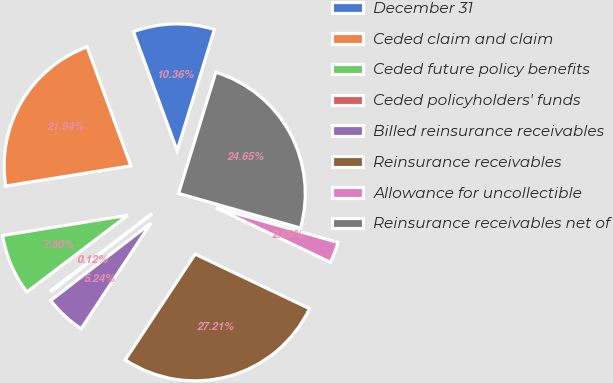Convert chart. <chart><loc_0><loc_0><loc_500><loc_500><pie_chart><fcel>December 31<fcel>Ceded claim and claim<fcel>Ceded future policy benefits<fcel>Ceded policyholders' funds<fcel>Billed reinsurance receivables<fcel>Reinsurance receivables<fcel>Allowance for uncollectible<fcel>Reinsurance receivables net of<nl><fcel>10.36%<fcel>21.94%<fcel>7.8%<fcel>0.12%<fcel>5.24%<fcel>27.21%<fcel>2.68%<fcel>24.65%<nl></chart> 